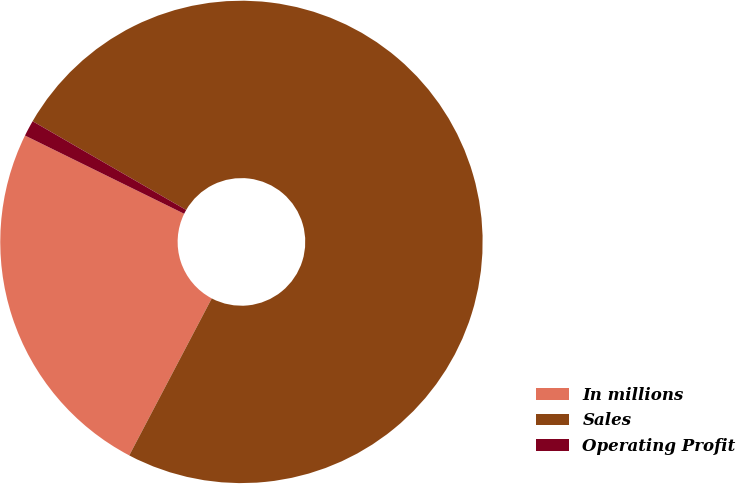Convert chart to OTSL. <chart><loc_0><loc_0><loc_500><loc_500><pie_chart><fcel>In millions<fcel>Sales<fcel>Operating Profit<nl><fcel>24.57%<fcel>74.36%<fcel>1.07%<nl></chart> 